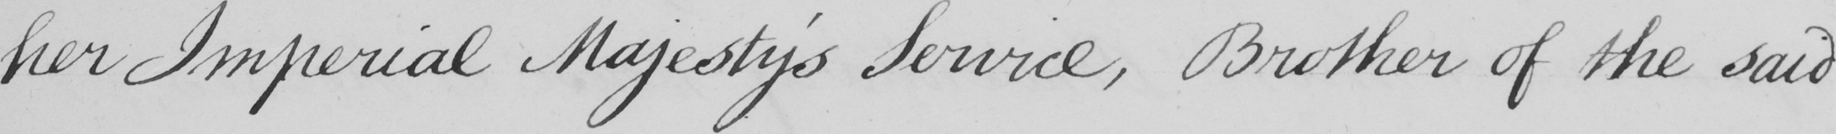Can you read and transcribe this handwriting? her Imperial Majesty's Service, Brother of the said 